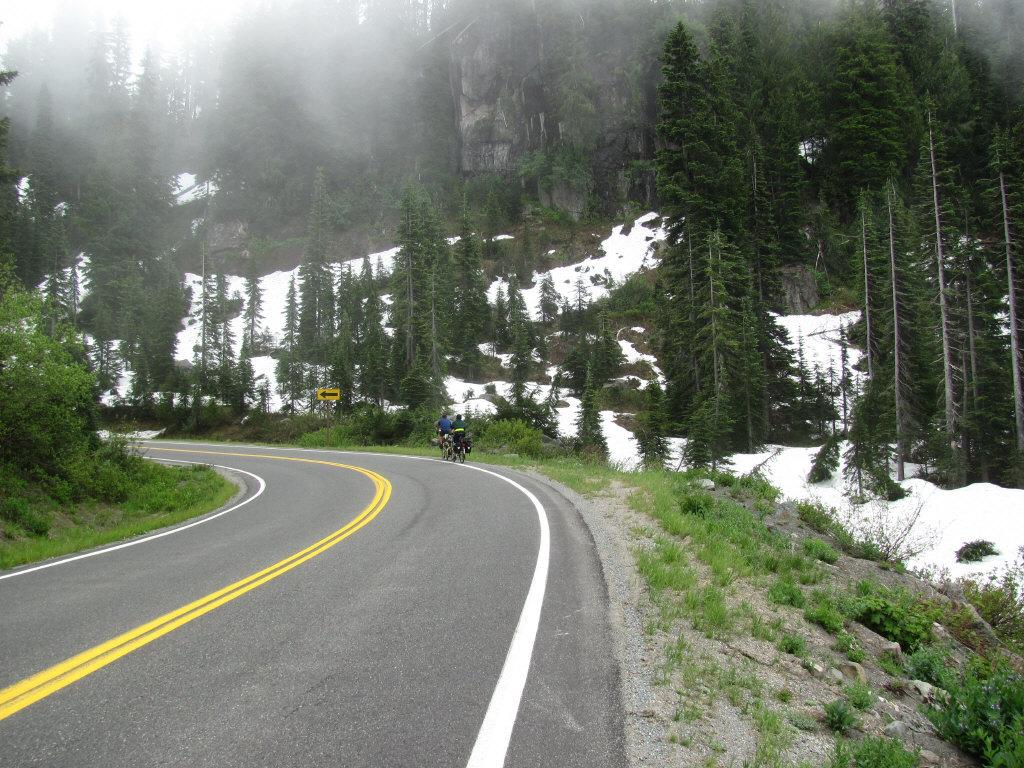How many people are in the image? There are two persons in the image. What are the two persons doing in the image? The two persons are sitting on a bicycle. Where are the two persons located in the image? They are on a road. What can be seen in the background of the image? There are trees and snow visible in the background. What color is the paint on the crib in the image? There is no crib present in the image, and therefore no paint to describe. 